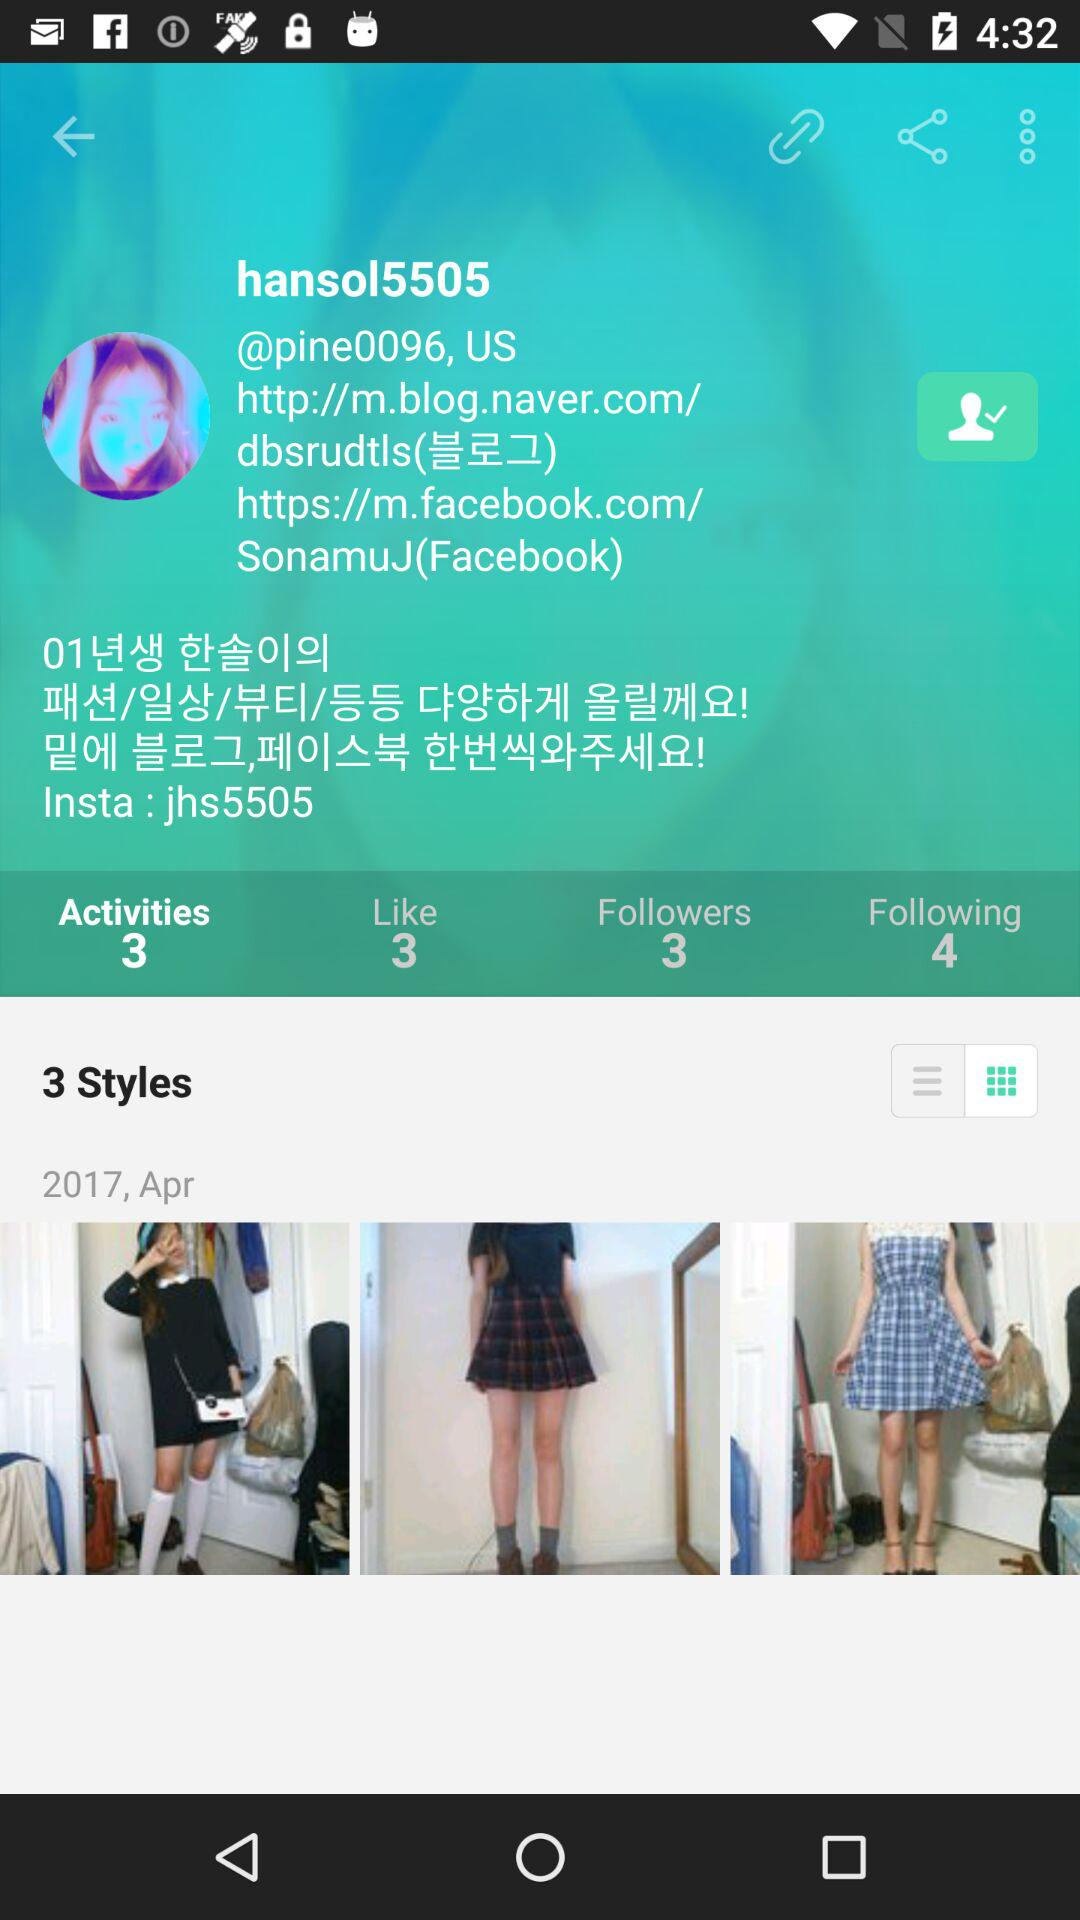What is the number of activities? The number of activities is 3. 